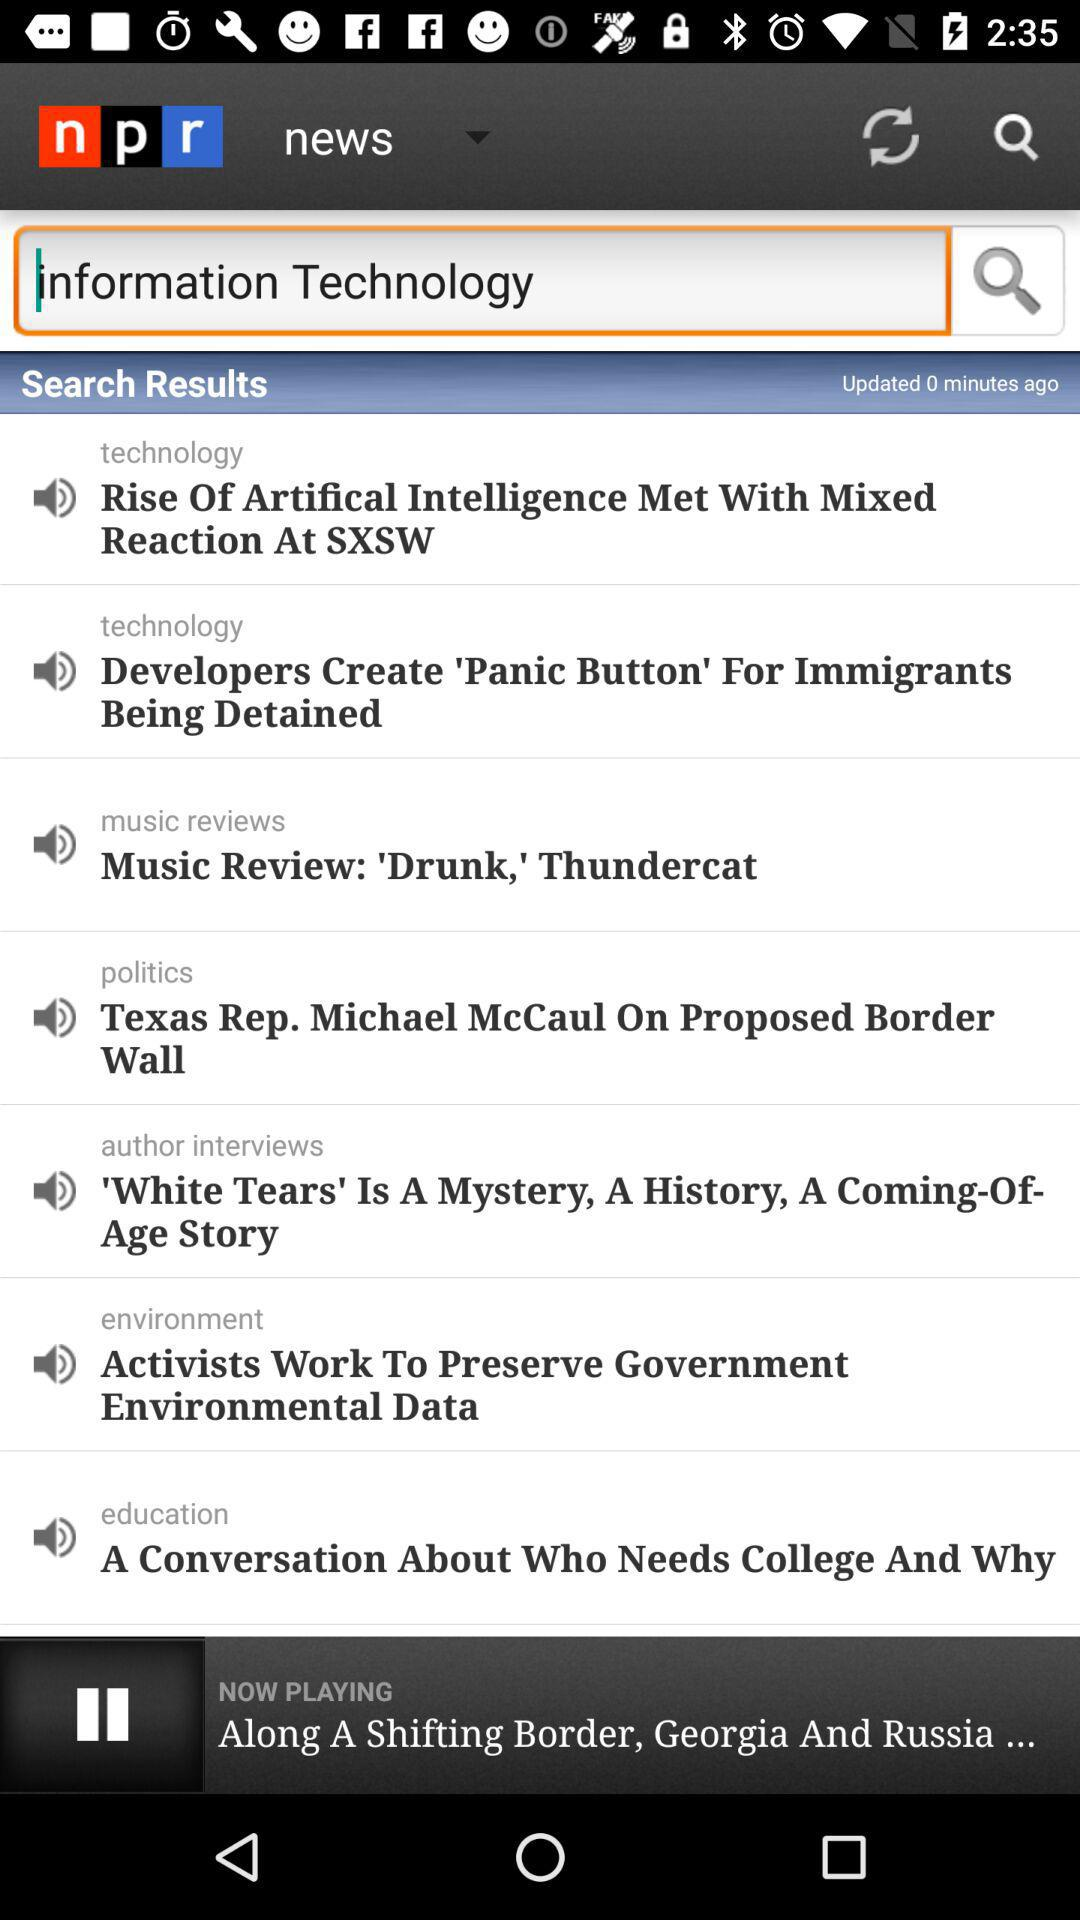Which news is playing? The playing news is "Along A Shifting Border, Georgia And Russia...". 